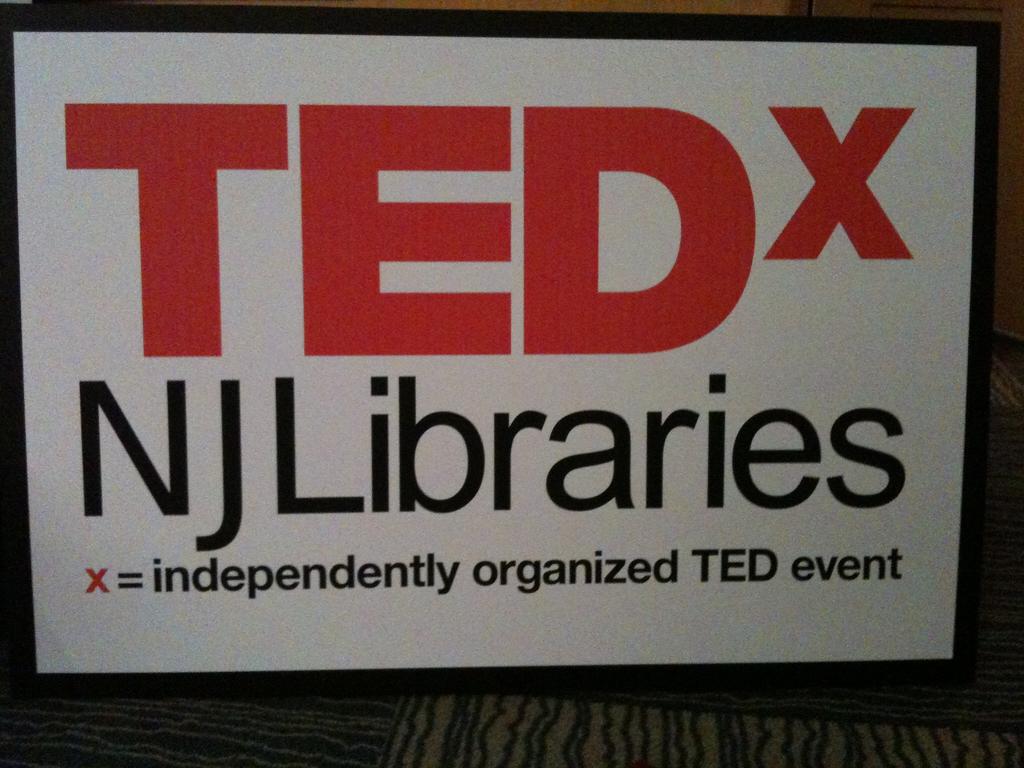What kind of libraries are these?
Your answer should be very brief. Nj. What company name is written in giant bold red letters?
Your response must be concise. Tedx. 